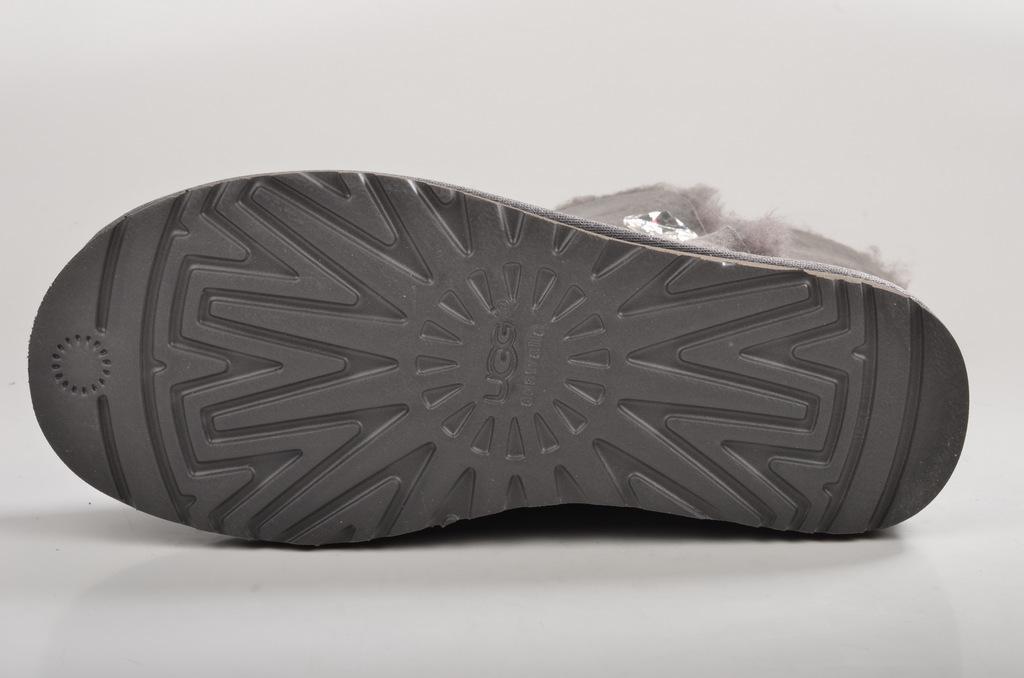Describe this image in one or two sentences. In this image I can see a shoe on the floor. This image is taken may be in a room. 